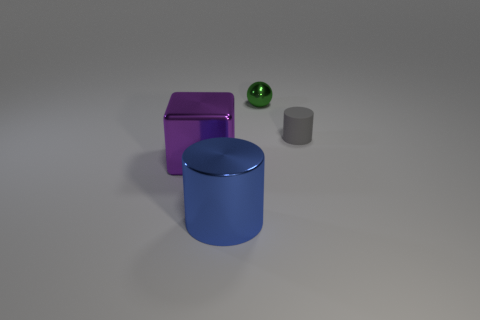Add 1 tiny things. How many objects exist? 5 Subtract all balls. How many objects are left? 3 Subtract all gray matte things. Subtract all large purple metallic blocks. How many objects are left? 2 Add 3 purple things. How many purple things are left? 4 Add 1 big blue metal cylinders. How many big blue metal cylinders exist? 2 Subtract 0 gray spheres. How many objects are left? 4 